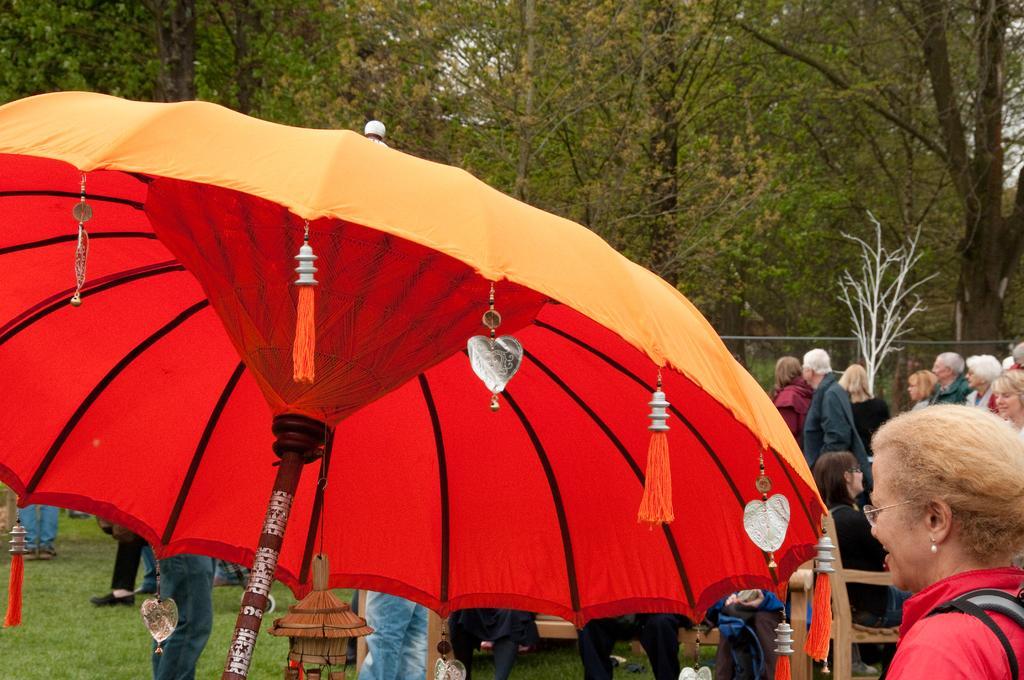Can you describe this image briefly? In this image there is a table umbrella. There are decorative things to the umbrella. Behind the umbrella there are many people standing and a few sitting on the ground. There is grass on the ground. In the background there are trees and a fence. 